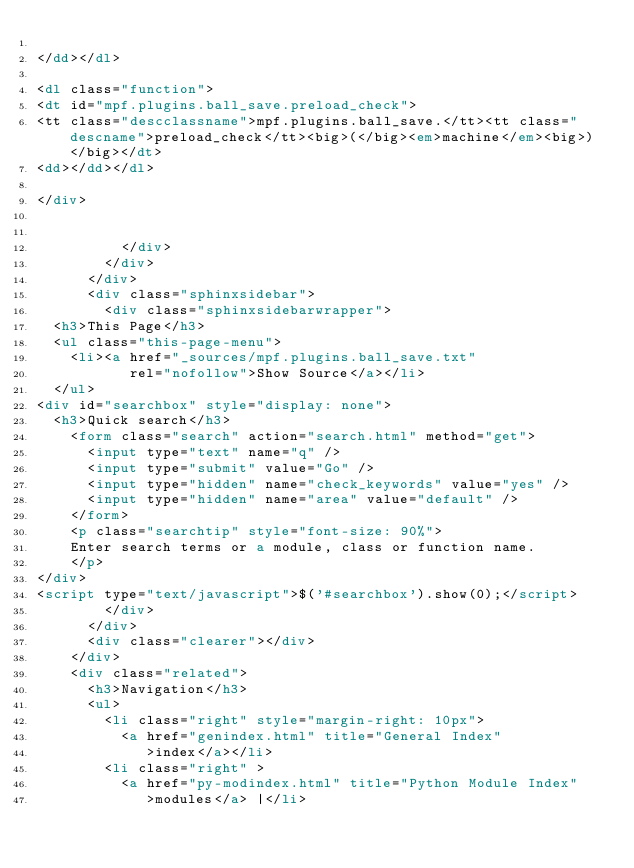<code> <loc_0><loc_0><loc_500><loc_500><_HTML_>
</dd></dl>

<dl class="function">
<dt id="mpf.plugins.ball_save.preload_check">
<tt class="descclassname">mpf.plugins.ball_save.</tt><tt class="descname">preload_check</tt><big>(</big><em>machine</em><big>)</big></dt>
<dd></dd></dl>

</div>


          </div>
        </div>
      </div>
      <div class="sphinxsidebar">
        <div class="sphinxsidebarwrapper">
  <h3>This Page</h3>
  <ul class="this-page-menu">
    <li><a href="_sources/mpf.plugins.ball_save.txt"
           rel="nofollow">Show Source</a></li>
  </ul>
<div id="searchbox" style="display: none">
  <h3>Quick search</h3>
    <form class="search" action="search.html" method="get">
      <input type="text" name="q" />
      <input type="submit" value="Go" />
      <input type="hidden" name="check_keywords" value="yes" />
      <input type="hidden" name="area" value="default" />
    </form>
    <p class="searchtip" style="font-size: 90%">
    Enter search terms or a module, class or function name.
    </p>
</div>
<script type="text/javascript">$('#searchbox').show(0);</script>
        </div>
      </div>
      <div class="clearer"></div>
    </div>
    <div class="related">
      <h3>Navigation</h3>
      <ul>
        <li class="right" style="margin-right: 10px">
          <a href="genindex.html" title="General Index"
             >index</a></li>
        <li class="right" >
          <a href="py-modindex.html" title="Python Module Index"
             >modules</a> |</li></code> 